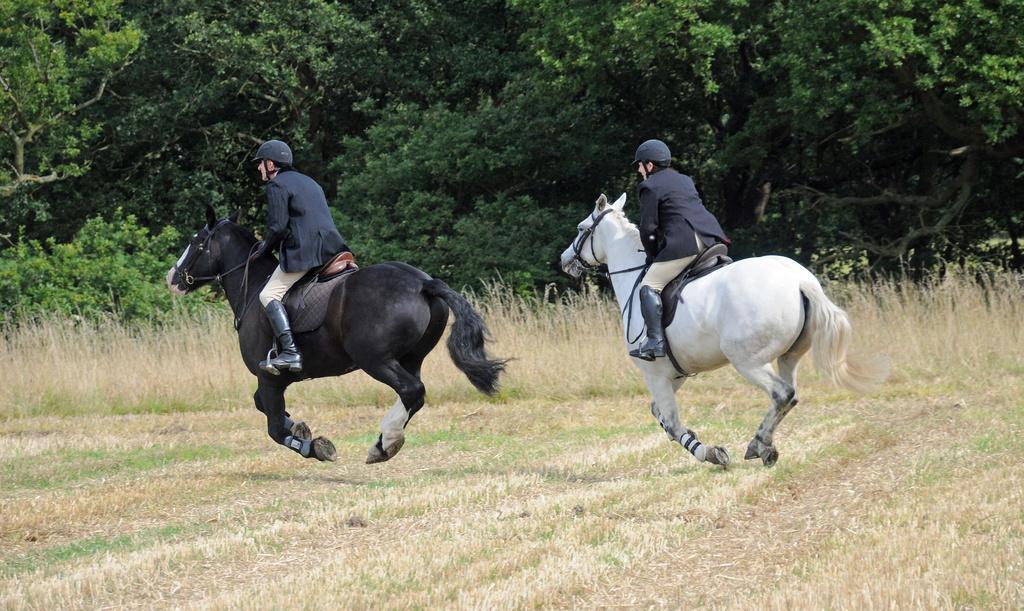Could you give a brief overview of what you see in this image? In this image I can see grass ground and on it I can see two persons are riding horses. I can see both of them are wearing shoes, blazers and helmets. In the background I can see bushes and number of trees. I can see colour of the one horse is black and colour of the another one is white. 